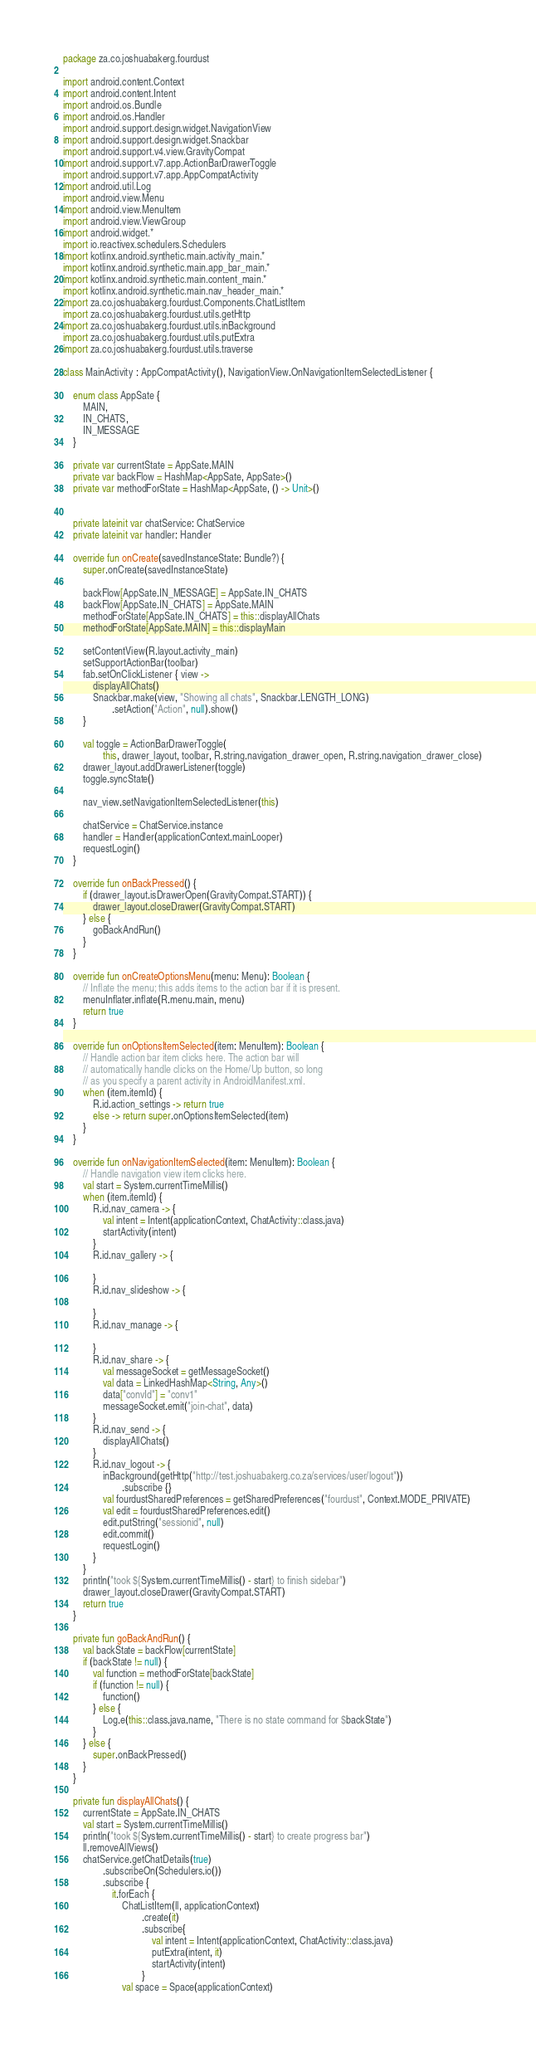<code> <loc_0><loc_0><loc_500><loc_500><_Kotlin_>package za.co.joshuabakerg.fourdust

import android.content.Context
import android.content.Intent
import android.os.Bundle
import android.os.Handler
import android.support.design.widget.NavigationView
import android.support.design.widget.Snackbar
import android.support.v4.view.GravityCompat
import android.support.v7.app.ActionBarDrawerToggle
import android.support.v7.app.AppCompatActivity
import android.util.Log
import android.view.Menu
import android.view.MenuItem
import android.view.ViewGroup
import android.widget.*
import io.reactivex.schedulers.Schedulers
import kotlinx.android.synthetic.main.activity_main.*
import kotlinx.android.synthetic.main.app_bar_main.*
import kotlinx.android.synthetic.main.content_main.*
import kotlinx.android.synthetic.main.nav_header_main.*
import za.co.joshuabakerg.fourdust.Components.ChatListItem
import za.co.joshuabakerg.fourdust.utils.getHttp
import za.co.joshuabakerg.fourdust.utils.inBackground
import za.co.joshuabakerg.fourdust.utils.putExtra
import za.co.joshuabakerg.fourdust.utils.traverse

class MainActivity : AppCompatActivity(), NavigationView.OnNavigationItemSelectedListener {

    enum class AppSate {
        MAIN,
        IN_CHATS,
        IN_MESSAGE
    }

    private var currentState = AppSate.MAIN
    private var backFlow = HashMap<AppSate, AppSate>()
    private var methodForState = HashMap<AppSate, () -> Unit>()


    private lateinit var chatService: ChatService
    private lateinit var handler: Handler

    override fun onCreate(savedInstanceState: Bundle?) {
        super.onCreate(savedInstanceState)

        backFlow[AppSate.IN_MESSAGE] = AppSate.IN_CHATS
        backFlow[AppSate.IN_CHATS] = AppSate.MAIN
        methodForState[AppSate.IN_CHATS] = this::displayAllChats
        methodForState[AppSate.MAIN] = this::displayMain

        setContentView(R.layout.activity_main)
        setSupportActionBar(toolbar)
        fab.setOnClickListener { view ->
            displayAllChats()
            Snackbar.make(view, "Showing all chats", Snackbar.LENGTH_LONG)
                    .setAction("Action", null).show()
        }

        val toggle = ActionBarDrawerToggle(
                this, drawer_layout, toolbar, R.string.navigation_drawer_open, R.string.navigation_drawer_close)
        drawer_layout.addDrawerListener(toggle)
        toggle.syncState()

        nav_view.setNavigationItemSelectedListener(this)

        chatService = ChatService.instance
        handler = Handler(applicationContext.mainLooper)
        requestLogin()
    }

    override fun onBackPressed() {
        if (drawer_layout.isDrawerOpen(GravityCompat.START)) {
            drawer_layout.closeDrawer(GravityCompat.START)
        } else {
            goBackAndRun()
        }
    }

    override fun onCreateOptionsMenu(menu: Menu): Boolean {
        // Inflate the menu; this adds items to the action bar if it is present.
        menuInflater.inflate(R.menu.main, menu)
        return true
    }

    override fun onOptionsItemSelected(item: MenuItem): Boolean {
        // Handle action bar item clicks here. The action bar will
        // automatically handle clicks on the Home/Up button, so long
        // as you specify a parent activity in AndroidManifest.xml.
        when (item.itemId) {
            R.id.action_settings -> return true
            else -> return super.onOptionsItemSelected(item)
        }
    }

    override fun onNavigationItemSelected(item: MenuItem): Boolean {
        // Handle navigation view item clicks here.
        val start = System.currentTimeMillis()
        when (item.itemId) {
            R.id.nav_camera -> {
                val intent = Intent(applicationContext, ChatActivity::class.java)
                startActivity(intent)
            }
            R.id.nav_gallery -> {

            }
            R.id.nav_slideshow -> {

            }
            R.id.nav_manage -> {

            }
            R.id.nav_share -> {
                val messageSocket = getMessageSocket()
                val data = LinkedHashMap<String, Any>()
                data["convId"] = "conv1"
                messageSocket.emit("join-chat", data)
            }
            R.id.nav_send -> {
                displayAllChats()
            }
            R.id.nav_logout -> {
                inBackground(getHttp("http://test.joshuabakerg.co.za/services/user/logout"))
                        .subscribe {}
                val fourdustSharedPreferences = getSharedPreferences("fourdust", Context.MODE_PRIVATE)
                val edit = fourdustSharedPreferences.edit()
                edit.putString("sessionid", null)
                edit.commit()
                requestLogin()
            }
        }
        println("took ${System.currentTimeMillis() - start} to finish sidebar")
        drawer_layout.closeDrawer(GravityCompat.START)
        return true
    }

    private fun goBackAndRun() {
        val backState = backFlow[currentState]
        if (backState != null) {
            val function = methodForState[backState]
            if (function != null) {
                function()
            } else {
                Log.e(this::class.java.name, "There is no state command for $backState")
            }
        } else {
            super.onBackPressed()
        }
    }

    private fun displayAllChats() {
        currentState = AppSate.IN_CHATS
        val start = System.currentTimeMillis()
        println("took ${System.currentTimeMillis() - start} to create progress bar")
        ll.removeAllViews()
        chatService.getChatDetails(true)
                .subscribeOn(Schedulers.io())
                .subscribe {
                    it.forEach {
                        ChatListItem(ll, applicationContext)
                                .create(it)
                                .subscribe{
                                    val intent = Intent(applicationContext, ChatActivity::class.java)
                                    putExtra(intent, it)
                                    startActivity(intent)
                                }
                        val space = Space(applicationContext)</code> 